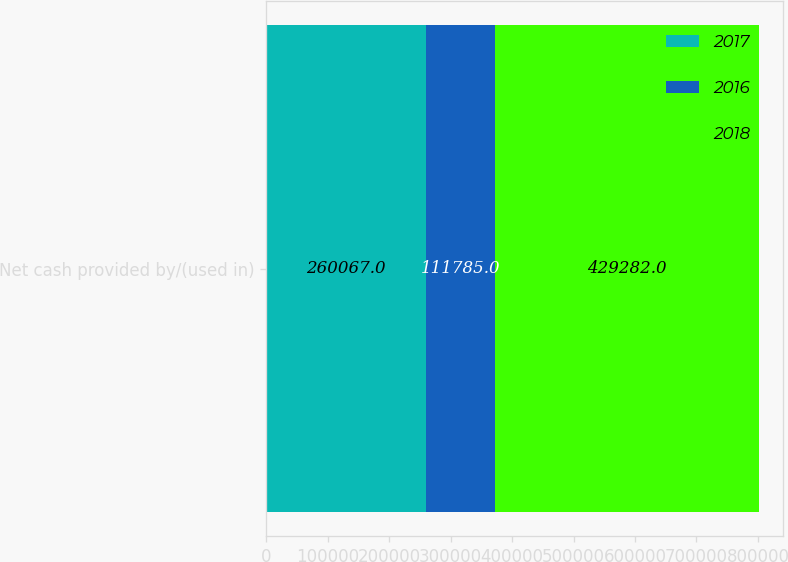<chart> <loc_0><loc_0><loc_500><loc_500><stacked_bar_chart><ecel><fcel>Net cash provided by/(used in)<nl><fcel>2017<fcel>260067<nl><fcel>2016<fcel>111785<nl><fcel>2018<fcel>429282<nl></chart> 